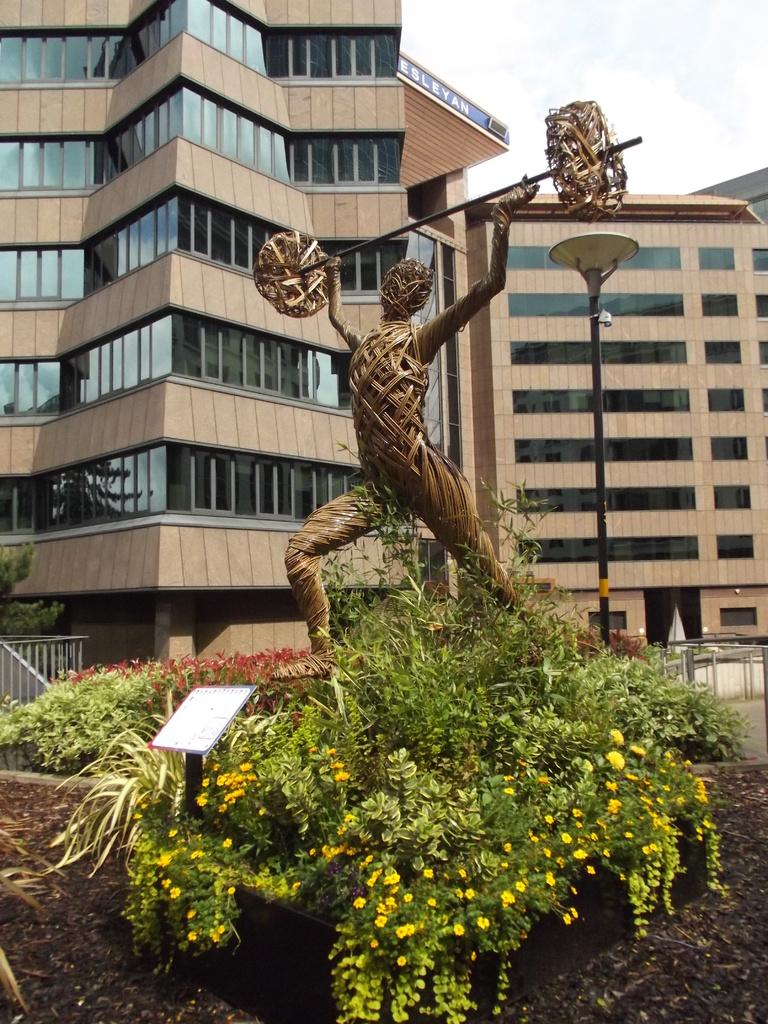What type of structures can be seen in the image? There are buildings in the image. What other elements are present in the image besides buildings? There are plants, flowers, a statue, a pole light, and a cloudy sky in the image. Can you describe the vegetation in the image? The image contains plants and flowers. What type of lighting is present in the image? There is a pole light in the image. How would you describe the weather in the image? The sky is cloudy in the image. Can you tell me how many beetles are crawling on the statue in the image? There are no beetles present in the image; the statue is not shown with any insects. What type of pancake is being served at the outdoor cafe in the image? There is no outdoor cafe or pancake present in the image. 